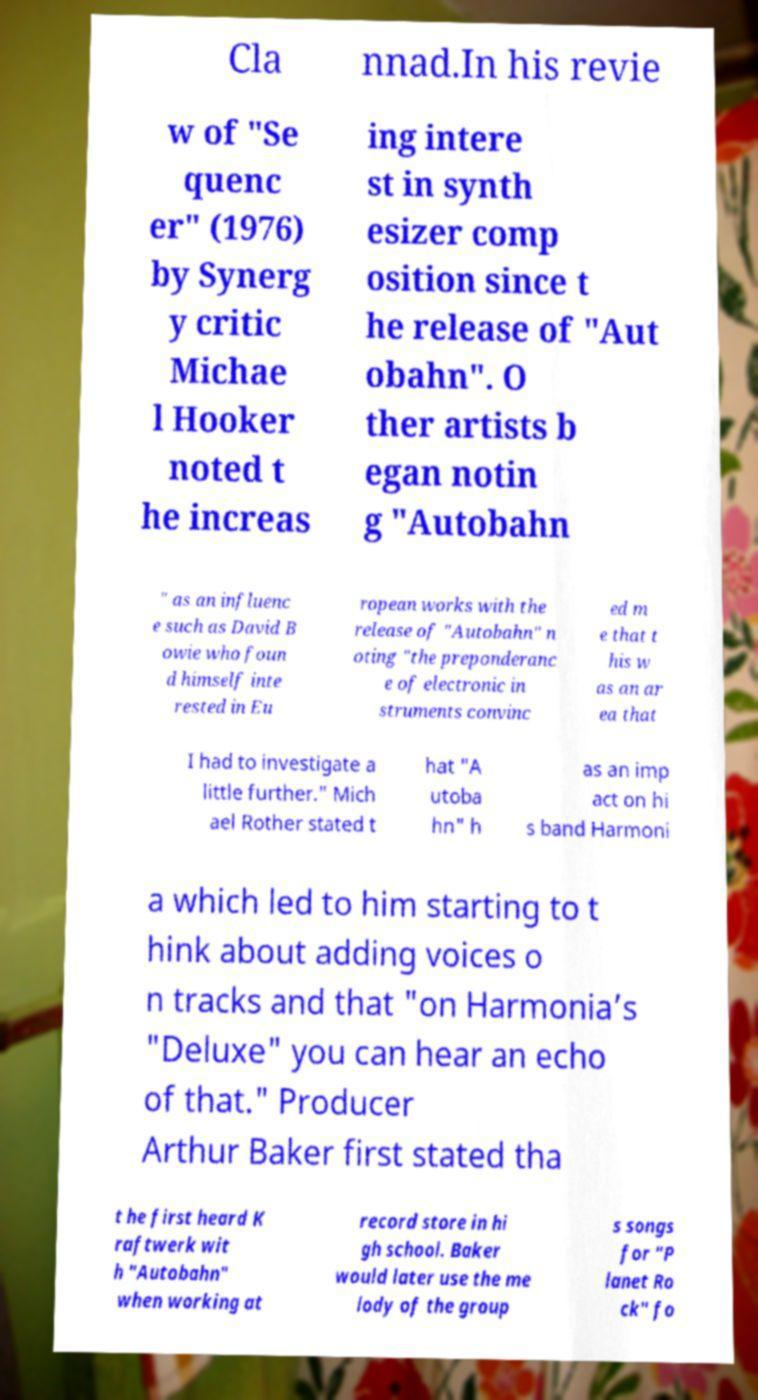Please read and relay the text visible in this image. What does it say? Cla nnad.In his revie w of "Se quenc er" (1976) by Synerg y critic Michae l Hooker noted t he increas ing intere st in synth esizer comp osition since t he release of "Aut obahn". O ther artists b egan notin g "Autobahn " as an influenc e such as David B owie who foun d himself inte rested in Eu ropean works with the release of "Autobahn" n oting "the preponderanc e of electronic in struments convinc ed m e that t his w as an ar ea that I had to investigate a little further." Mich ael Rother stated t hat "A utoba hn" h as an imp act on hi s band Harmoni a which led to him starting to t hink about adding voices o n tracks and that "on Harmonia’s "Deluxe" you can hear an echo of that." Producer Arthur Baker first stated tha t he first heard K raftwerk wit h "Autobahn" when working at record store in hi gh school. Baker would later use the me lody of the group s songs for "P lanet Ro ck" fo 